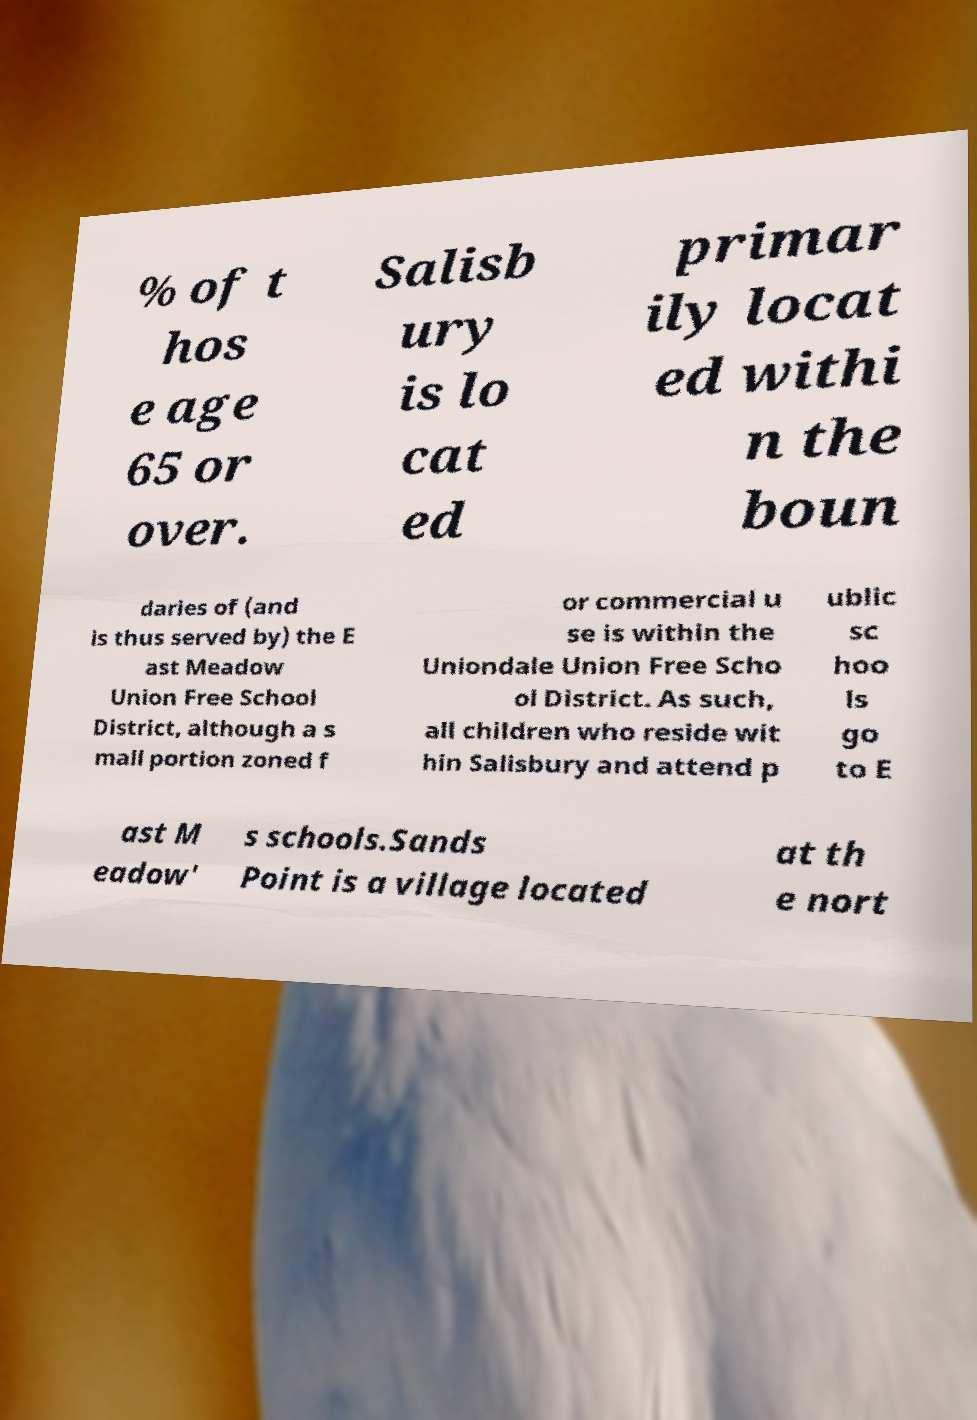Please read and relay the text visible in this image. What does it say? % of t hos e age 65 or over. Salisb ury is lo cat ed primar ily locat ed withi n the boun daries of (and is thus served by) the E ast Meadow Union Free School District, although a s mall portion zoned f or commercial u se is within the Uniondale Union Free Scho ol District. As such, all children who reside wit hin Salisbury and attend p ublic sc hoo ls go to E ast M eadow' s schools.Sands Point is a village located at th e nort 